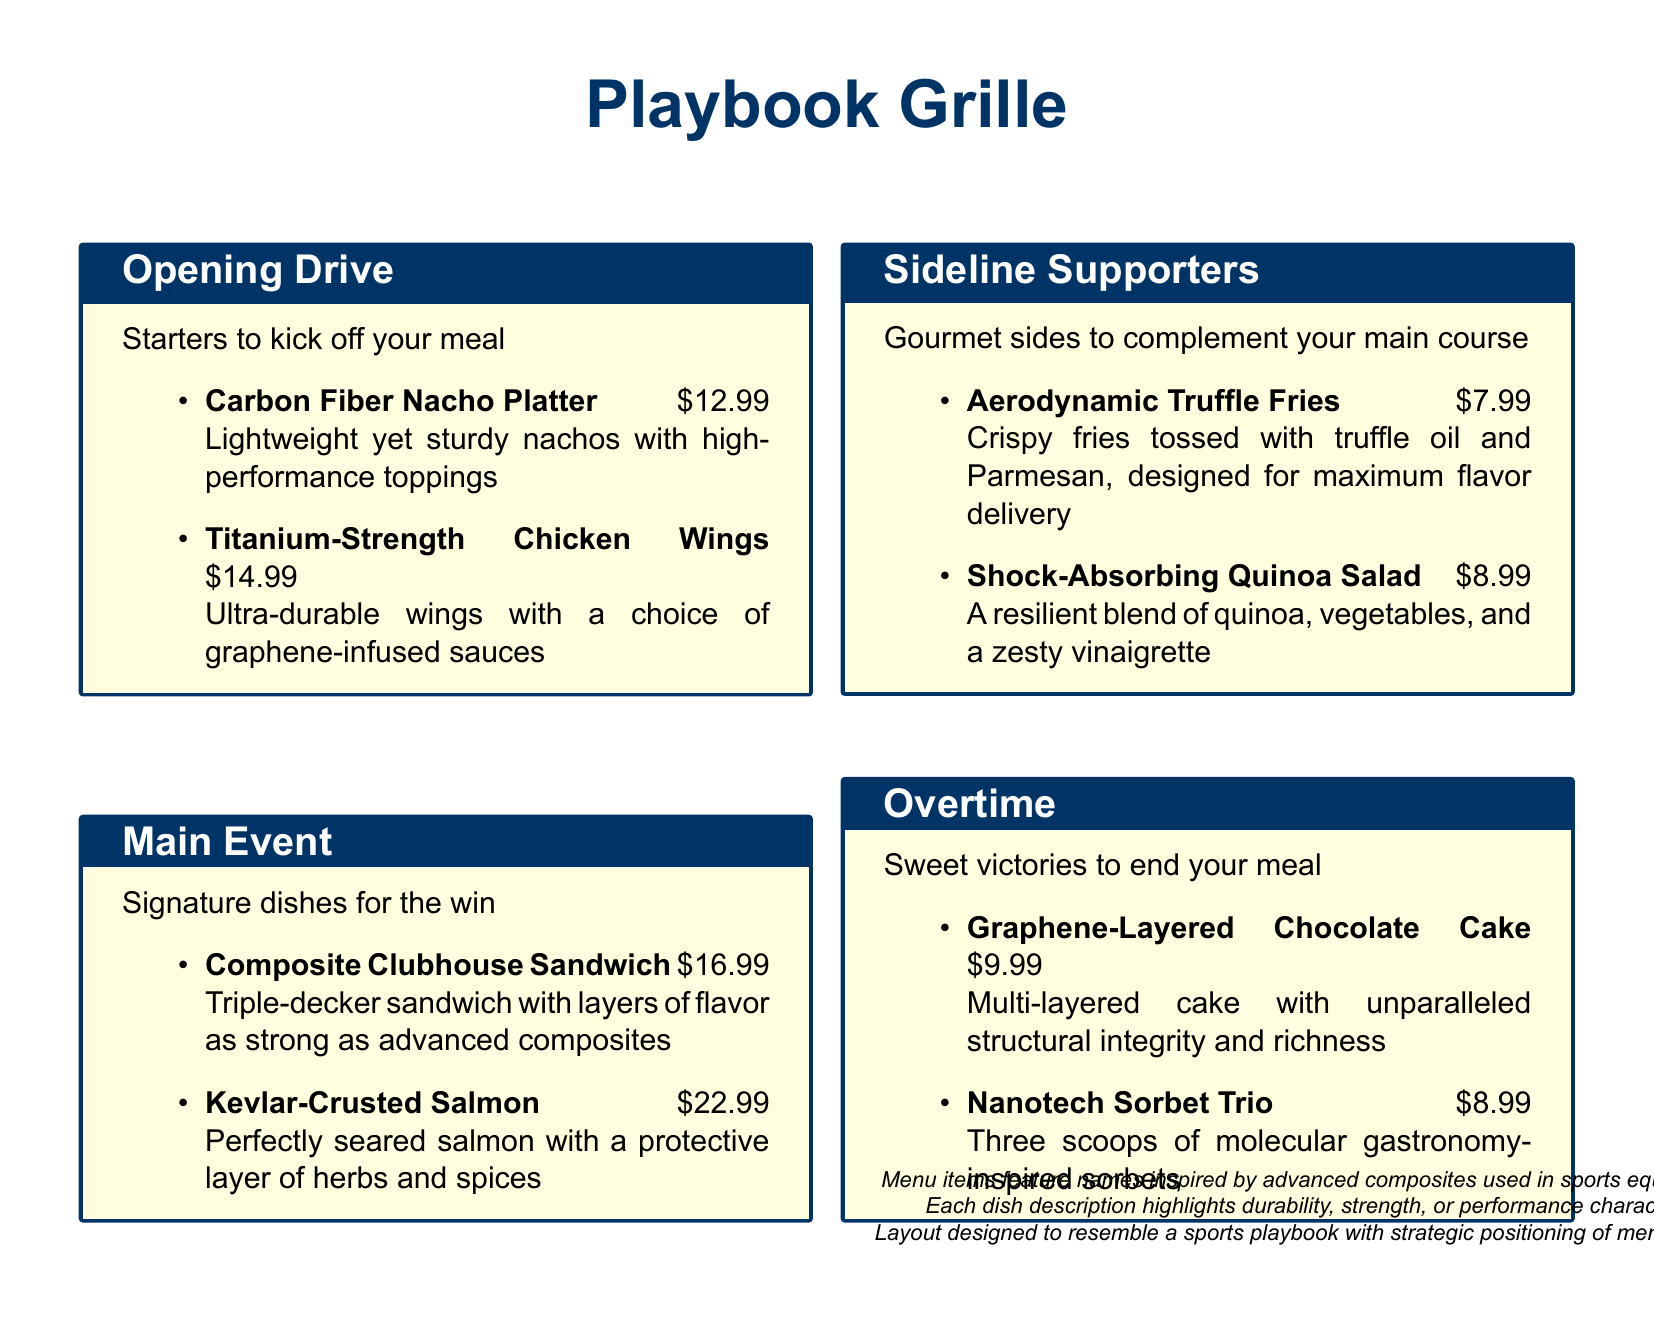What is the name of the restaurant? The name of the restaurant is stated at the top of the menu.
Answer: Playbook Grille What is the price of the Kevlar-Crusted Salmon? The price is found next to the dish name in the Main Event section.
Answer: $22.99 How many items are listed in the Sideline Supporters section? The total number of items can be counted in that section of the menu.
Answer: 2 What type of dessert is included in Overtime? This involves identifying the dish types mentioned in the Overtime section.
Answer: Sweet victories What are the Carbon Fiber Nacho Platter toppings described as? The toppings are mentioned in relation to the nachos in the Opening Drive section.
Answer: High-performance toppings Which dish has a price of $14.99? This requires locating the price detail in the Opening Drive section.
Answer: Titanium-Strength Chicken Wings What is the main theme of the menu's naming convention? The theme is highlighted in the introductory notes at the bottom of the document.
Answer: Advanced composites Which starter is designed for maximum flavor delivery? This involves recalling the specific description from the Sideline Supporters section.
Answer: Aerodynamic Truffle Fries How is the Graphene-Layered Chocolate Cake described in terms of structure? This description is found in the Overtime section, focusing on cake characteristics.
Answer: Unparalleled structural integrity 